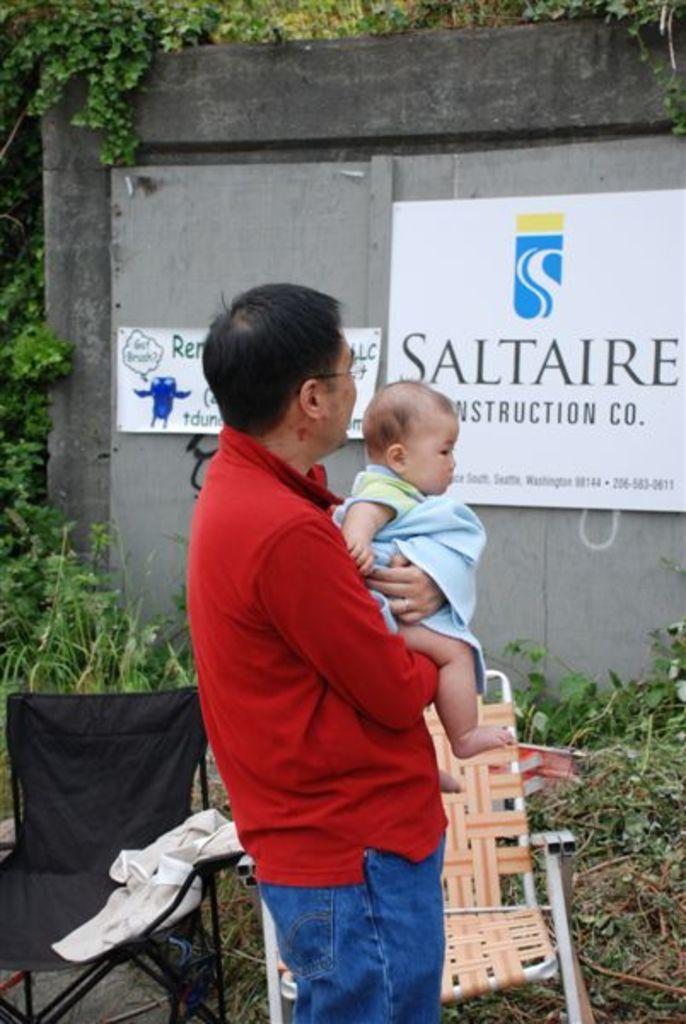Can you describe this image briefly? In this picture there is a man who is holding a baby. Besides him I can see two chairs. In the back I can see the banners which are placed on the wooden wall. Beside the wall I can see the plants and tree. 